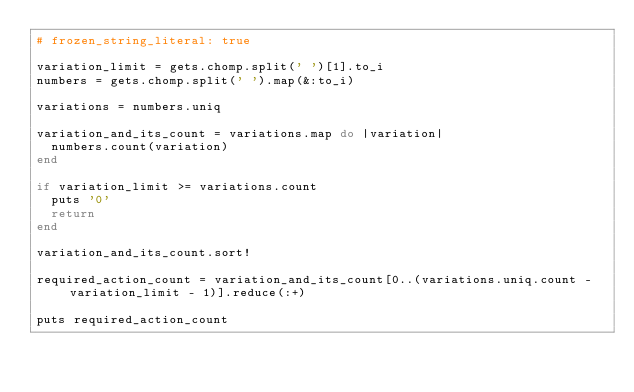Convert code to text. <code><loc_0><loc_0><loc_500><loc_500><_Ruby_># frozen_string_literal: true

variation_limit = gets.chomp.split(' ')[1].to_i
numbers = gets.chomp.split(' ').map(&:to_i)

variations = numbers.uniq

variation_and_its_count = variations.map do |variation|
  numbers.count(variation)
end

if variation_limit >= variations.count
  puts '0'
  return
end

variation_and_its_count.sort!

required_action_count = variation_and_its_count[0..(variations.uniq.count - variation_limit - 1)].reduce(:+)

puts required_action_count
</code> 